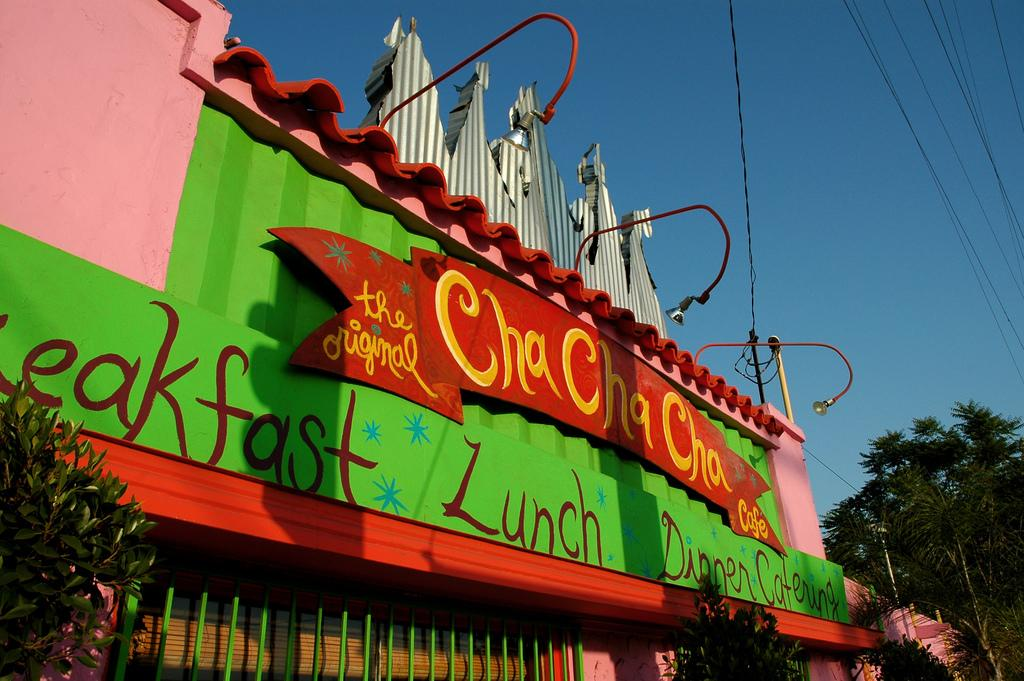What type of structure is visible in the image? There is a house in the image. What feature is present on the house? The house has a signboard. What part of the house is mentioned in the facts? The house has a roof. What type of vegetation can be seen in the image? There are plants and trees in the image. What type of lighting is present in the image? There are street lamps in the image. What else can be seen in the image? There is a pole and wires in the image. What is visible in the background of the image? The sky is visible in the image, and it appears cloudy. Can you see any sea creatures swimming in the image? There is no sea or sea creatures present in the image. What type of farm animals can be seen grazing in the image? There is no farm or farm animals present in the image. 